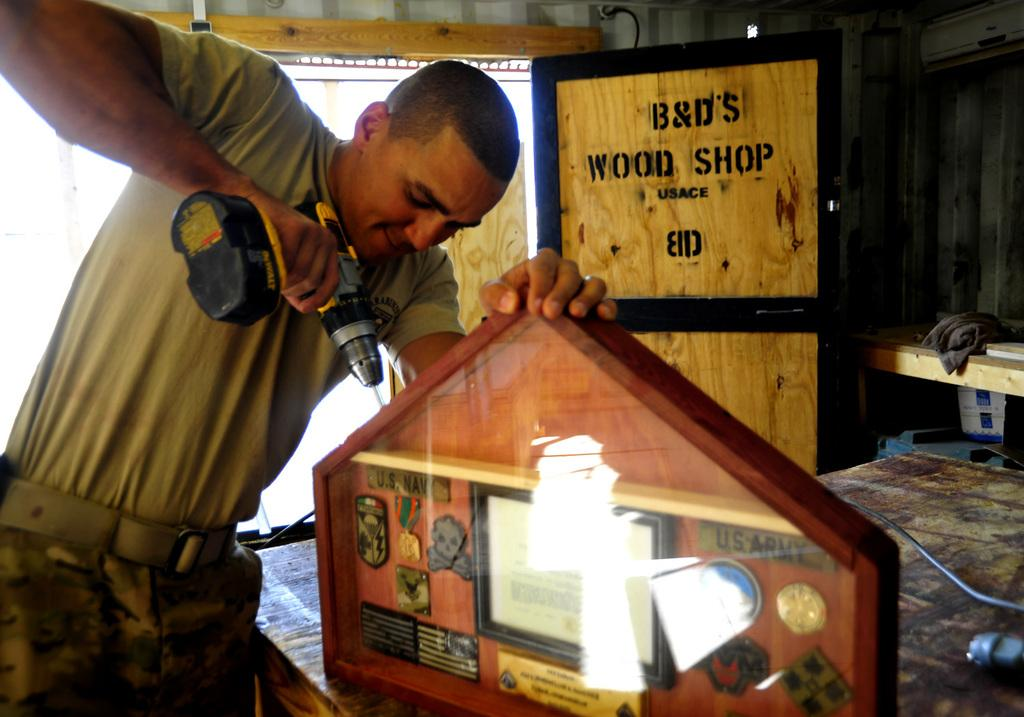<image>
Summarize the visual content of the image. A man using a drill on piece of wood from B&D's Wood Shop. 